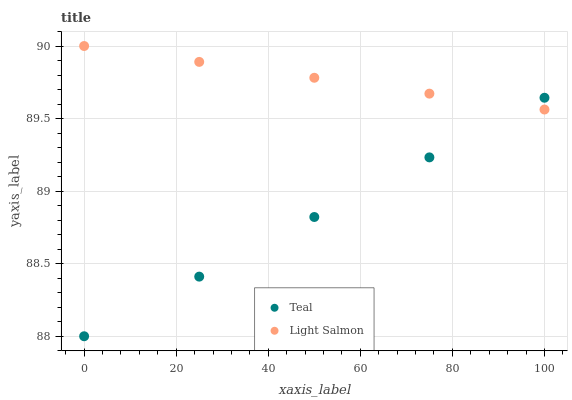Does Teal have the minimum area under the curve?
Answer yes or no. Yes. Does Light Salmon have the maximum area under the curve?
Answer yes or no. Yes. Does Teal have the maximum area under the curve?
Answer yes or no. No. Is Light Salmon the smoothest?
Answer yes or no. Yes. Is Teal the roughest?
Answer yes or no. Yes. Does Teal have the lowest value?
Answer yes or no. Yes. Does Light Salmon have the highest value?
Answer yes or no. Yes. Does Teal have the highest value?
Answer yes or no. No. Does Light Salmon intersect Teal?
Answer yes or no. Yes. Is Light Salmon less than Teal?
Answer yes or no. No. Is Light Salmon greater than Teal?
Answer yes or no. No. 